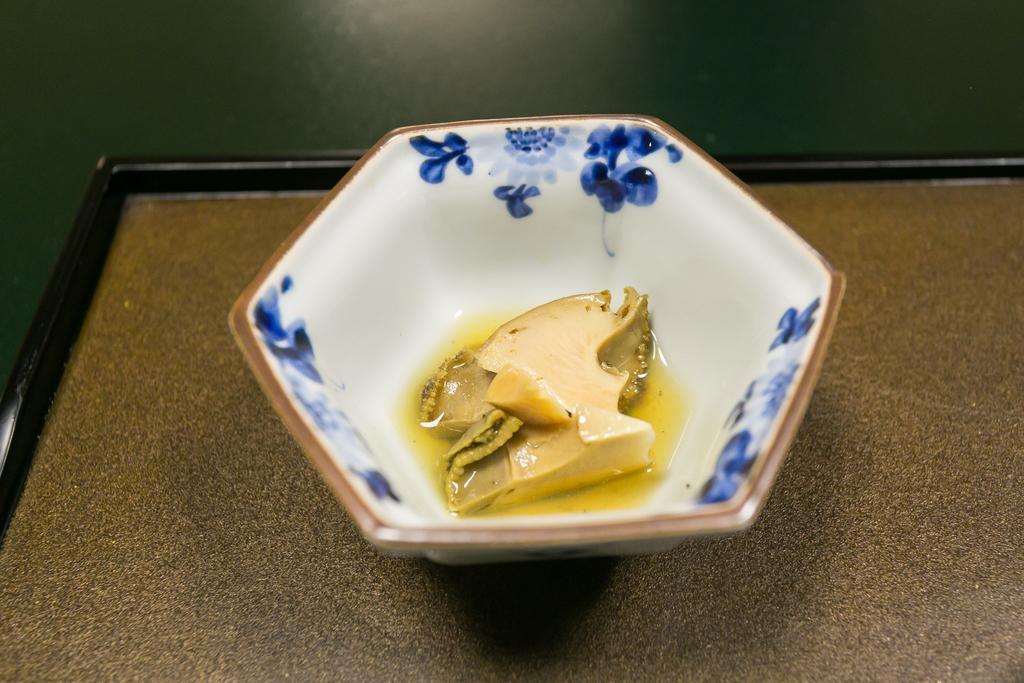Describe this image in one or two sentences. In this picture we can observe a white color bowl. There is a blue color design on this bowl. We can observe some food in this bowl. This bowl is placed on the brown color table. The background is in green color. 